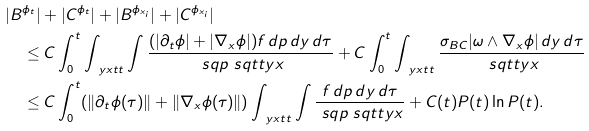Convert formula to latex. <formula><loc_0><loc_0><loc_500><loc_500>& | B ^ { \phi _ { t } } | + | C ^ { \phi _ { t } } | + | B ^ { \phi _ { x _ { i } } } | + | C ^ { \phi _ { x _ { i } } } | \\ & \quad \leq C \int ^ { t } _ { 0 } \int _ { \ y x t t } \int \frac { ( | \partial _ { t } \phi | + | \nabla _ { x } \phi | ) f \, d p \, d y \, d \tau } { \ s q p \ s q t t y x } + C \int ^ { t } _ { 0 } \int _ { \ y x t t } \frac { \sigma _ { B C } | \omega \wedge \nabla _ { x } \phi | \, d y \, d \tau } { \ s q t t y x } \\ & \quad \leq C \int ^ { t } _ { 0 } ( \| \partial _ { t } \phi ( \tau ) \| + \| \nabla _ { x } \phi ( \tau ) \| ) \int _ { \ y x t t } \int \frac { f \, d p \, d y \, d \tau } { \ s q p \ s q t t y x } + C ( t ) P ( t ) \ln P ( t ) .</formula> 